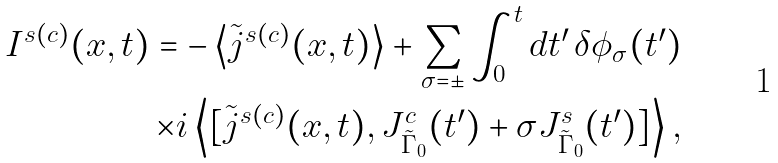<formula> <loc_0><loc_0><loc_500><loc_500>I ^ { s ( c ) } ( x , t ) = - \left \langle \tilde { j } ^ { s ( c ) } ( x , t ) \right \rangle + \sum _ { \sigma = \pm } \int _ { 0 } ^ { t } d t ^ { \prime } \, \delta \phi _ { \sigma } ( t ^ { \prime } ) \\ \times i \left \langle [ \tilde { j } ^ { s ( c ) } ( x , t ) , J ^ { c } _ { \tilde { \Gamma } _ { 0 } } ( t ^ { \prime } ) + \sigma J ^ { s } _ { \tilde { \Gamma } _ { 0 } } ( t ^ { \prime } ) ] \right \rangle ,</formula> 